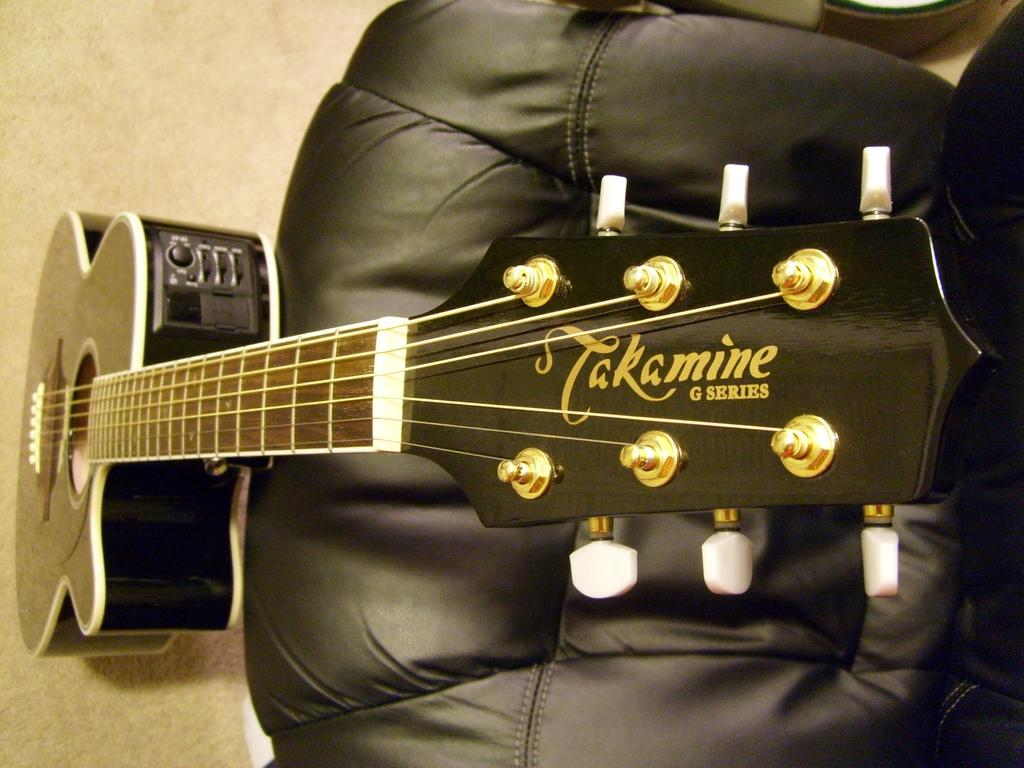What musical instrument is present in the image? There is a guitar in the image. What is the color of the guitar? The guitar is black in color. Where is the guitar placed in relation to other objects in the image? The guitar is placed near a chair. What is the color of the chair? The chair is also black in color. Can you tell me how many berries are on the guitar in the image? There are no berries present on the guitar in the image. What type of iron material is used to make the chair in the image? The chair's material is not mentioned in the image, and there is no indication of it being made of iron. 